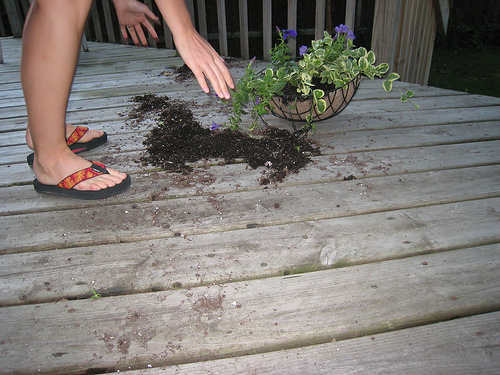<image>
Can you confirm if the person is above the dirt? Yes. The person is positioned above the dirt in the vertical space, higher up in the scene. 